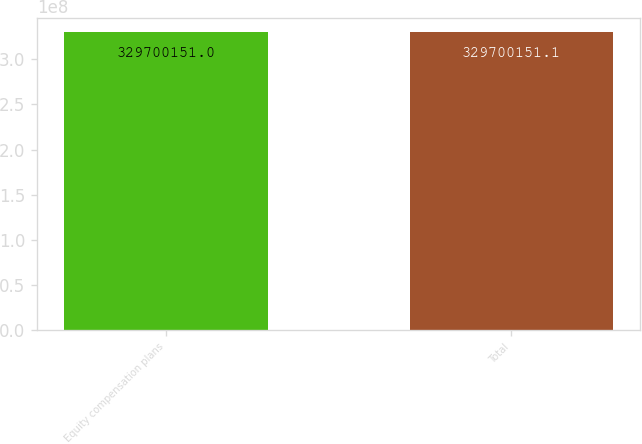Convert chart to OTSL. <chart><loc_0><loc_0><loc_500><loc_500><bar_chart><fcel>Equity compensation plans<fcel>Total<nl><fcel>3.297e+08<fcel>3.297e+08<nl></chart> 